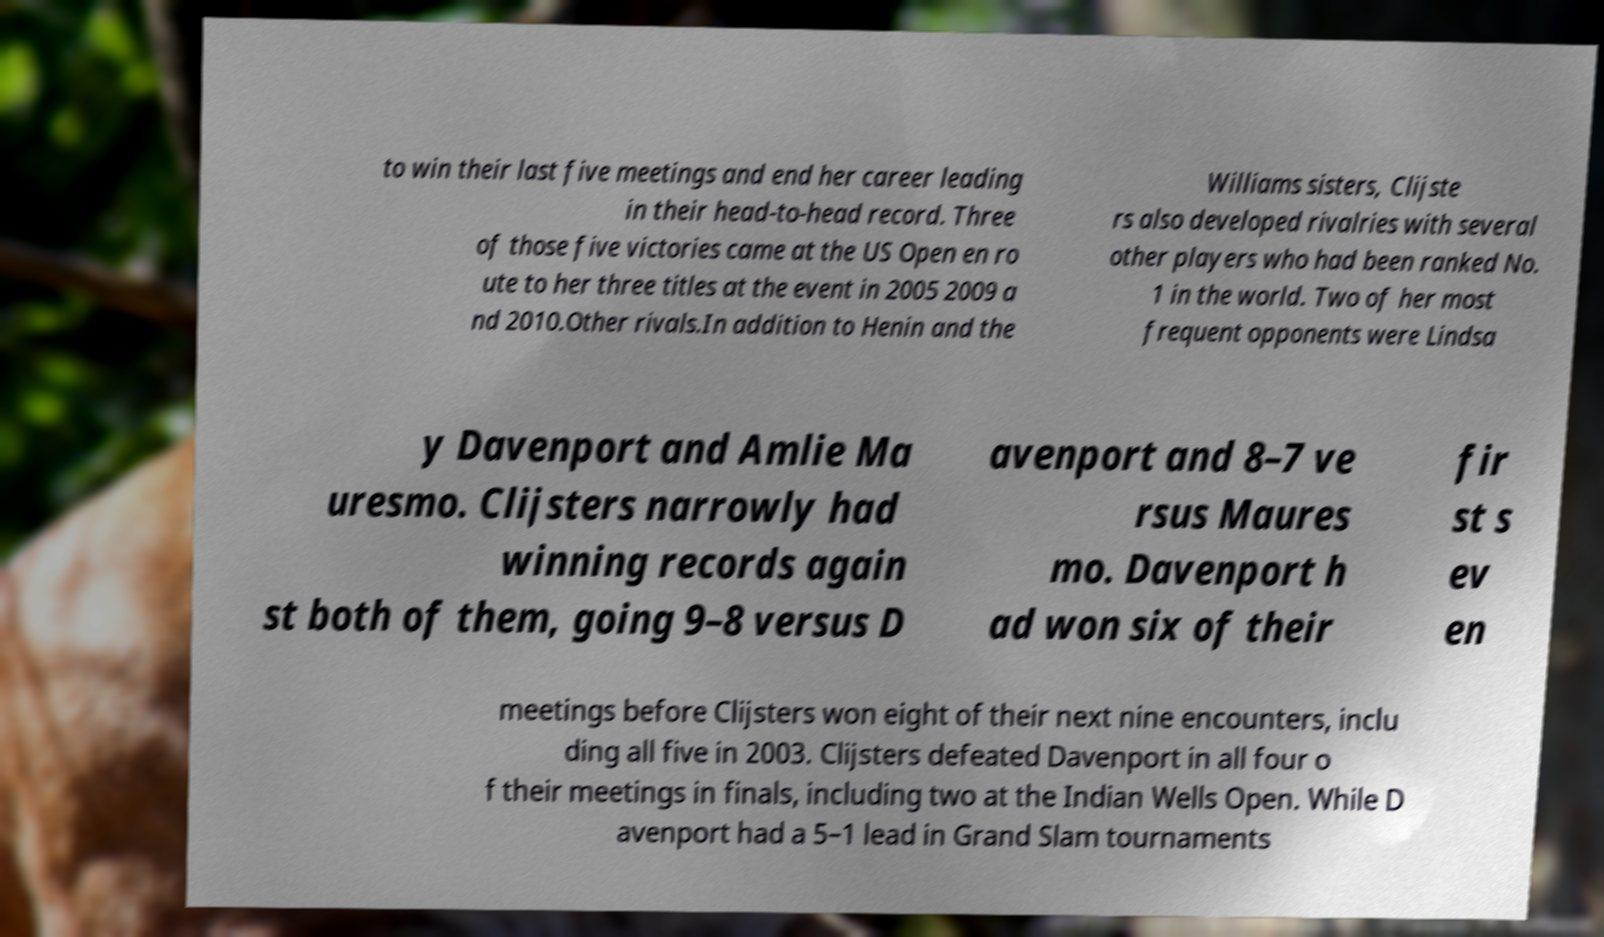There's text embedded in this image that I need extracted. Can you transcribe it verbatim? to win their last five meetings and end her career leading in their head-to-head record. Three of those five victories came at the US Open en ro ute to her three titles at the event in 2005 2009 a nd 2010.Other rivals.In addition to Henin and the Williams sisters, Clijste rs also developed rivalries with several other players who had been ranked No. 1 in the world. Two of her most frequent opponents were Lindsa y Davenport and Amlie Ma uresmo. Clijsters narrowly had winning records again st both of them, going 9–8 versus D avenport and 8–7 ve rsus Maures mo. Davenport h ad won six of their fir st s ev en meetings before Clijsters won eight of their next nine encounters, inclu ding all five in 2003. Clijsters defeated Davenport in all four o f their meetings in finals, including two at the Indian Wells Open. While D avenport had a 5–1 lead in Grand Slam tournaments 